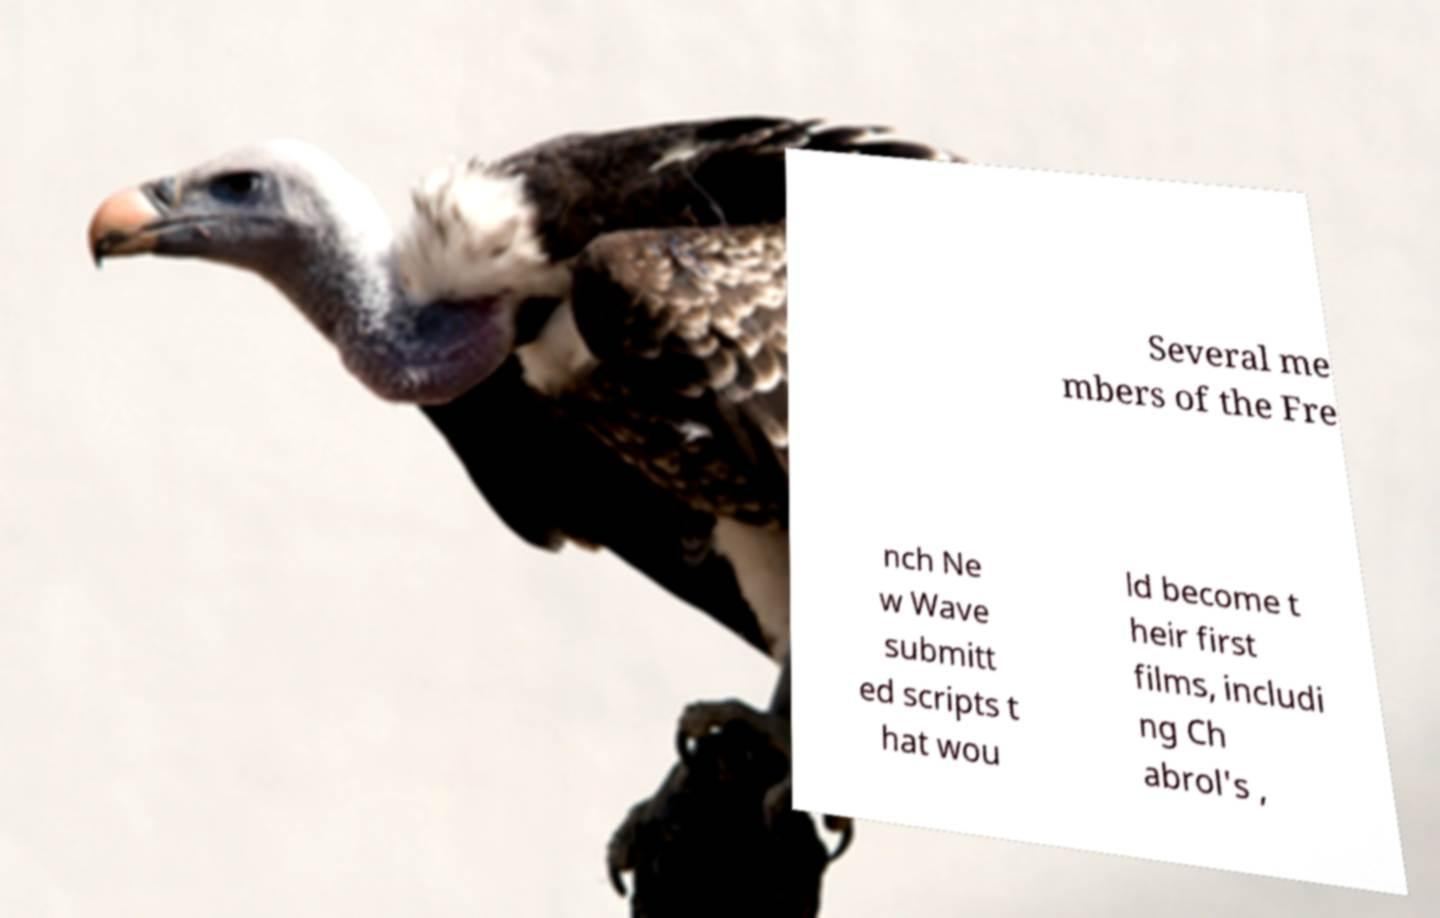Could you assist in decoding the text presented in this image and type it out clearly? Several me mbers of the Fre nch Ne w Wave submitt ed scripts t hat wou ld become t heir first films, includi ng Ch abrol's , 